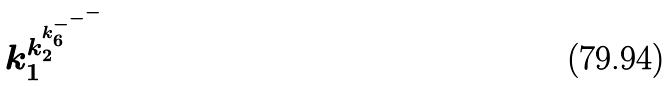Convert formula to latex. <formula><loc_0><loc_0><loc_500><loc_500>k _ { 1 } ^ { k _ { 2 } ^ { k _ { 6 } ^ { - ^ { - ^ { - } } } } }</formula> 